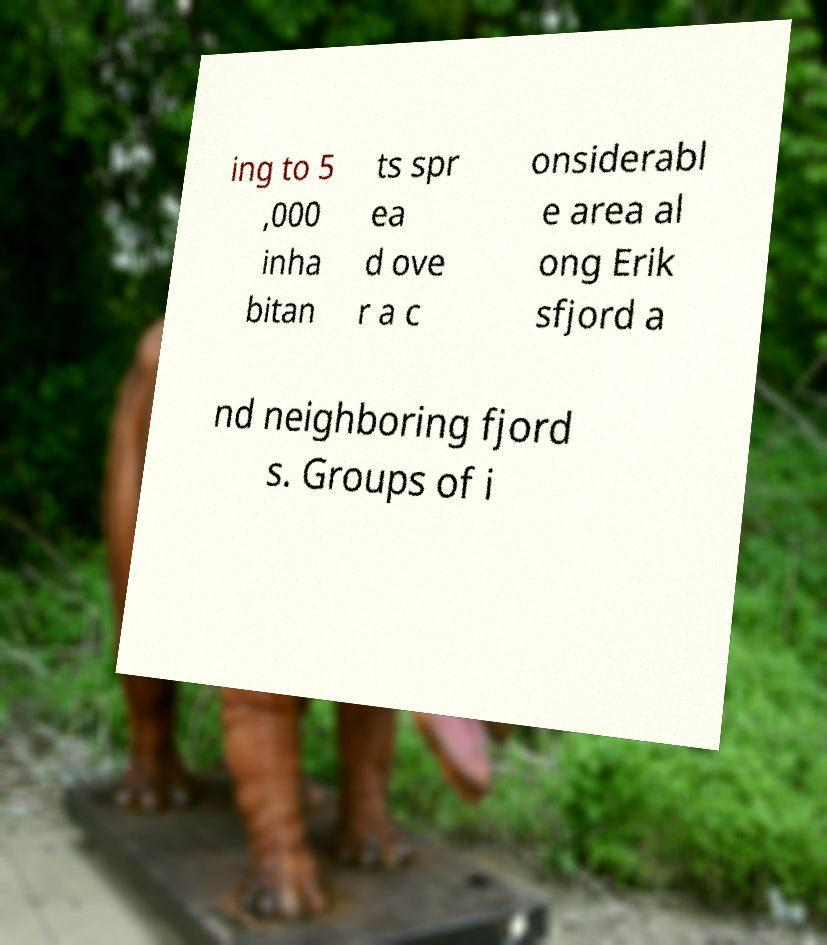What messages or text are displayed in this image? I need them in a readable, typed format. ing to 5 ,000 inha bitan ts spr ea d ove r a c onsiderabl e area al ong Erik sfjord a nd neighboring fjord s. Groups of i 